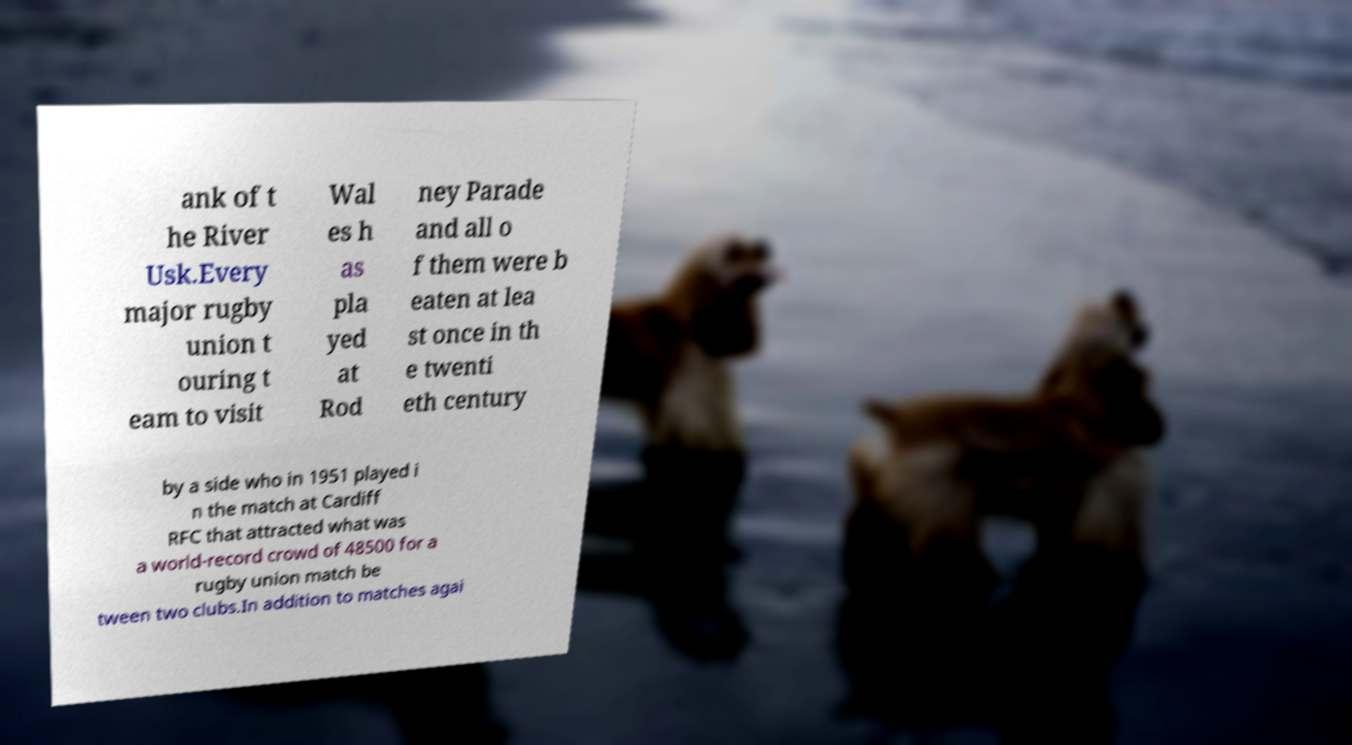What messages or text are displayed in this image? I need them in a readable, typed format. ank of t he River Usk.Every major rugby union t ouring t eam to visit Wal es h as pla yed at Rod ney Parade and all o f them were b eaten at lea st once in th e twenti eth century by a side who in 1951 played i n the match at Cardiff RFC that attracted what was a world-record crowd of 48500 for a rugby union match be tween two clubs.In addition to matches agai 